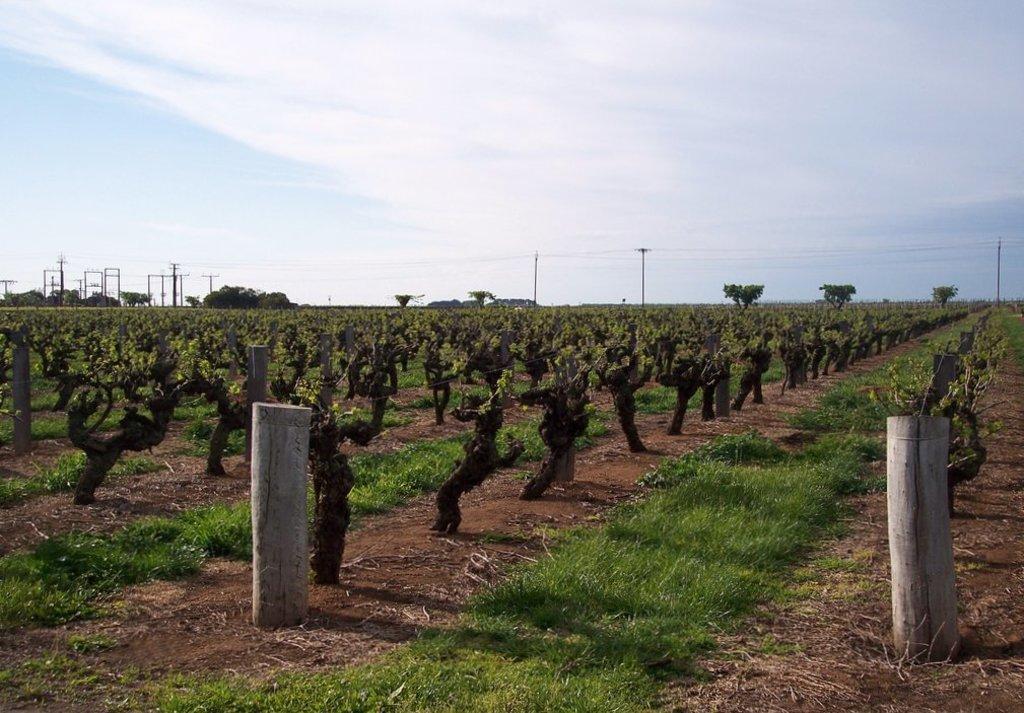In one or two sentences, can you explain what this image depicts? This picture is taken from outside of the city. In this image, on the right side, we can see a wooden trunk. On the left side, we can also see a wooden trunk. In the background, we can see some trees, plants, electric pole, electric wires. At the top, we can see a sky which is a bit cloudy, at the bottom, we can see a grass and a land with some stones. 